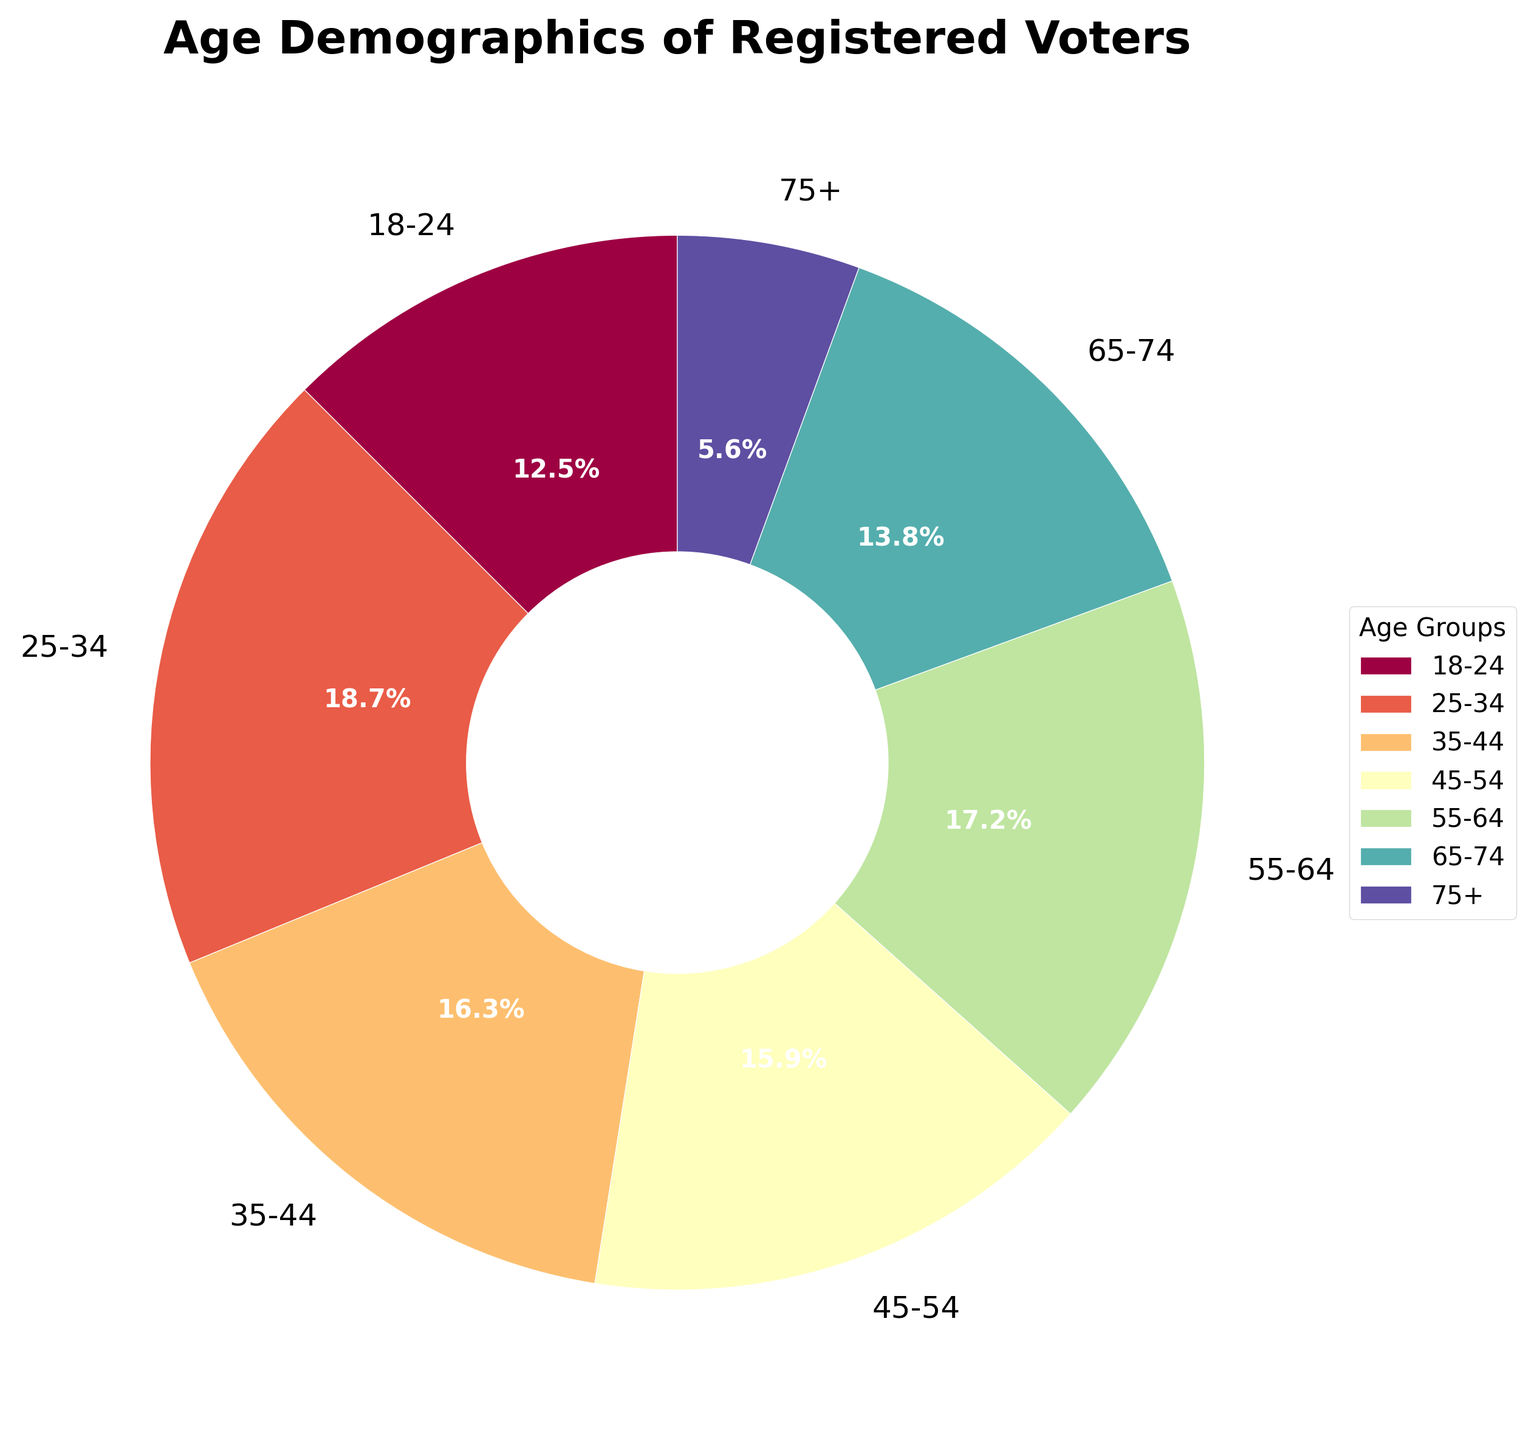Which age group has the highest percentage of registered voters? The pie chart shows the percentage of voter registration for each age group. By identifying the segment with the largest portion, we observe that the 25-34 age group has the highest percentage.
Answer: 25-34 What is the combined percentage of registered voters aged 55+? Sum the percentages of the 55-64, 65-74, and 75+ age groups. Therefore, 17.2% (55-64) + 13.8% (65-74) + 5.6% (75+) = 36.6%.
Answer: 36.6% Which two age groups have nearly the same percentage of registered voters? The chart shows percentages closely resembling those of the age groups 35-44 (16.3%) and 45-54 (15.9%). Both percentages are similar.
Answer: 35-44 and 45-54 What is the difference in the percentage of registered voters between the 18-24 and 25-34 age groups? Subtract the percentage of the 18-24 age group from that of the 25-34 age group: 18.7% (25-34) - 12.5% (18-24) = 6.2%.
Answer: 6.2% Which age group has the smallest percentage of registered voters? By visual inspection of the pie chart, the smallest segment belongs to the 75+ age group, with 5.6%.
Answer: 75+ What is the average percentage of registered voters for the 25-34, 35-44, and 45-54 age groups? Sum the percentages of the 25-34, 35-44, and 45-54 age groups and divide by 3. Therefore, (18.7% + 16.3% + 15.9%) / 3 = 16.97%.
Answer: 16.97% How does the percentage of the 65-74 age group compare to the 18-24 age group? The percentage of the 65-74 age group (13.8%) is slightly higher than that of the 18-24 age group (12.5%), by a difference of 1.3%.
Answer: 65-74 higher than 18-24 by 1.3% If the pie chart’s colors start from red at 18-24 and end with blue at 75+, which color indicates the 45-54 age group? The colors change as depicted in the chart from red to blue, indicating the 45-54 age group has a color between those intervals, likely green or closest to green.
Answer: green or closest to green What is the total percentage of registered voters younger than 35 years? Sum the percentages of the 18-24 and 25-34 age groups. Therefore, 12.5% (18-24) + 18.7% (25-34) = 31.2%.
Answer: 31.2% 